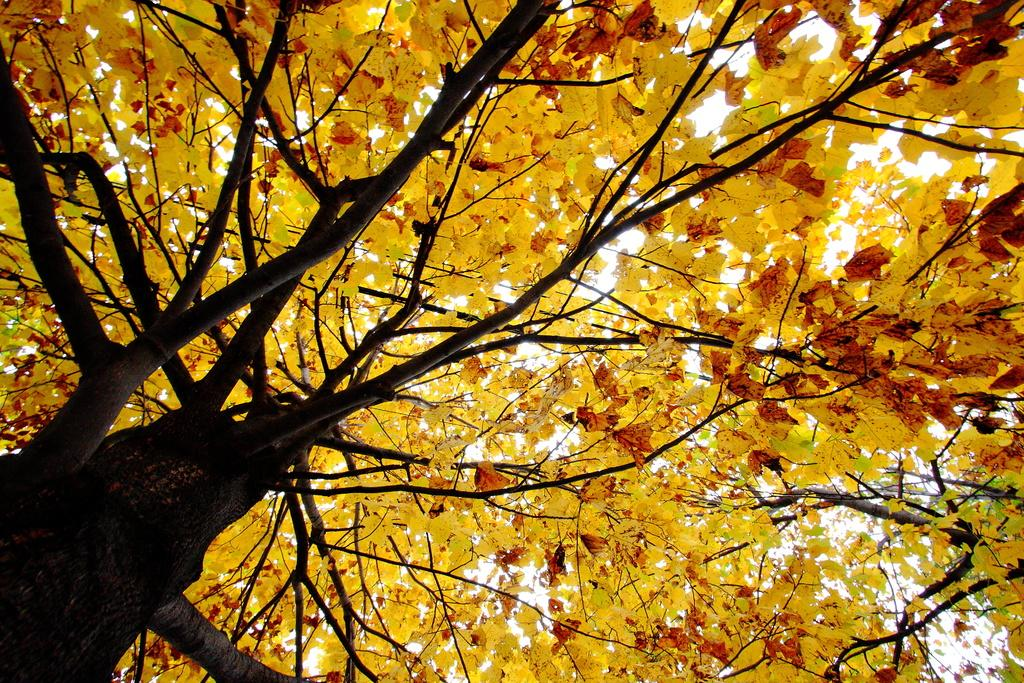What is present in the image? There is a tree in the image. What is unique about the tree's appearance? The tree has yellow leaves. What type of temper does the banana have in the image? There is no banana present in the image, so it is not possible to determine its temper. 